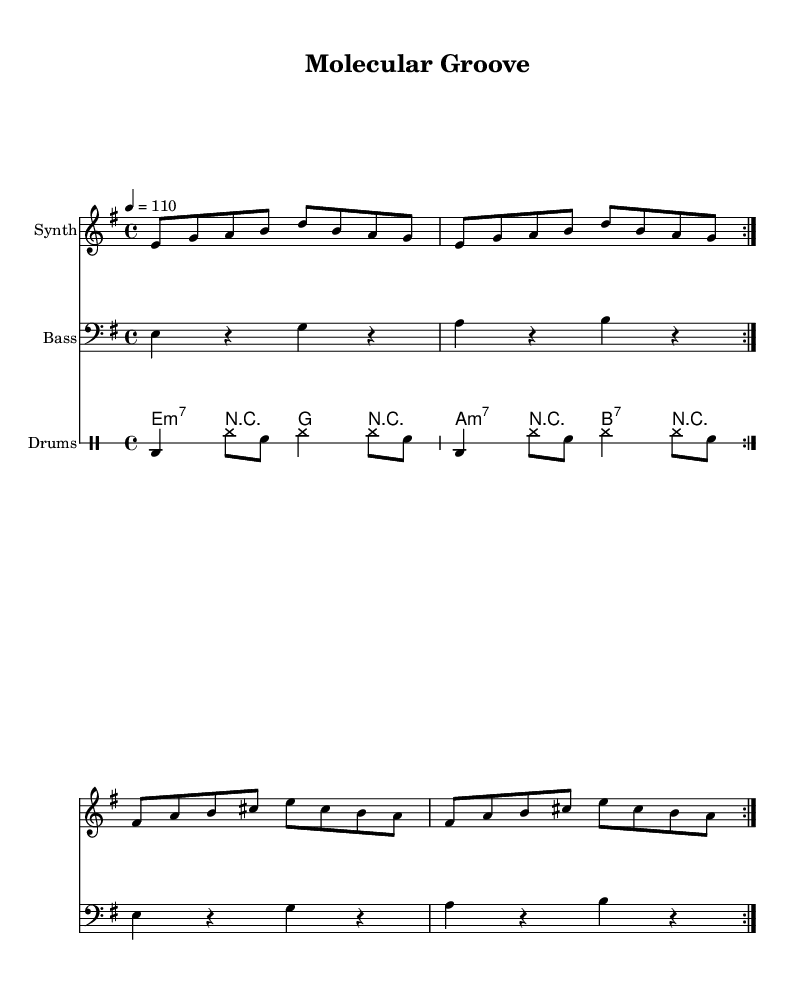What is the key signature of this music? The key signature is E minor, which has one sharp (F#) indicated at the beginning of the staff.
Answer: E minor What is the time signature of this music? The time signature is 4/4, as indicated at the beginning of the score, which means there are four beats in each measure.
Answer: 4/4 What is the tempo marking of this piece? The tempo marking indicates a speed of quarter note equals 110 beats per minute, denoted by the "4 = 110" at the beginning of the score.
Answer: 110 How many measures are repeated in the melody section? The melody section has two measures repeated as indicated by the "repeat volta 2" instruction which applies to the entire melody.
Answer: 2 What type of chord is played in the guitar riff during the first measure? The first measure of the guitar riff indicates an E minor seventh chord (e:m7) with the corresponding bass notes following the chord structure in the riff.
Answer: E minor seventh Which instrument has a bass clef in this score? The Bass staff is explicitly mentioned to have a bass clef, which allows low-pitched instruments to read the music properly.
Answer: Bass What is the primary rhythmic pattern of the drum section? The drum section primarily features a repetitive pattern consisting of bass drum (bd), hi-hat (hh), and snare (sn) across the measures, showcasing classic funk drumming techniques.
Answer: Bass, hi-hat, snare 